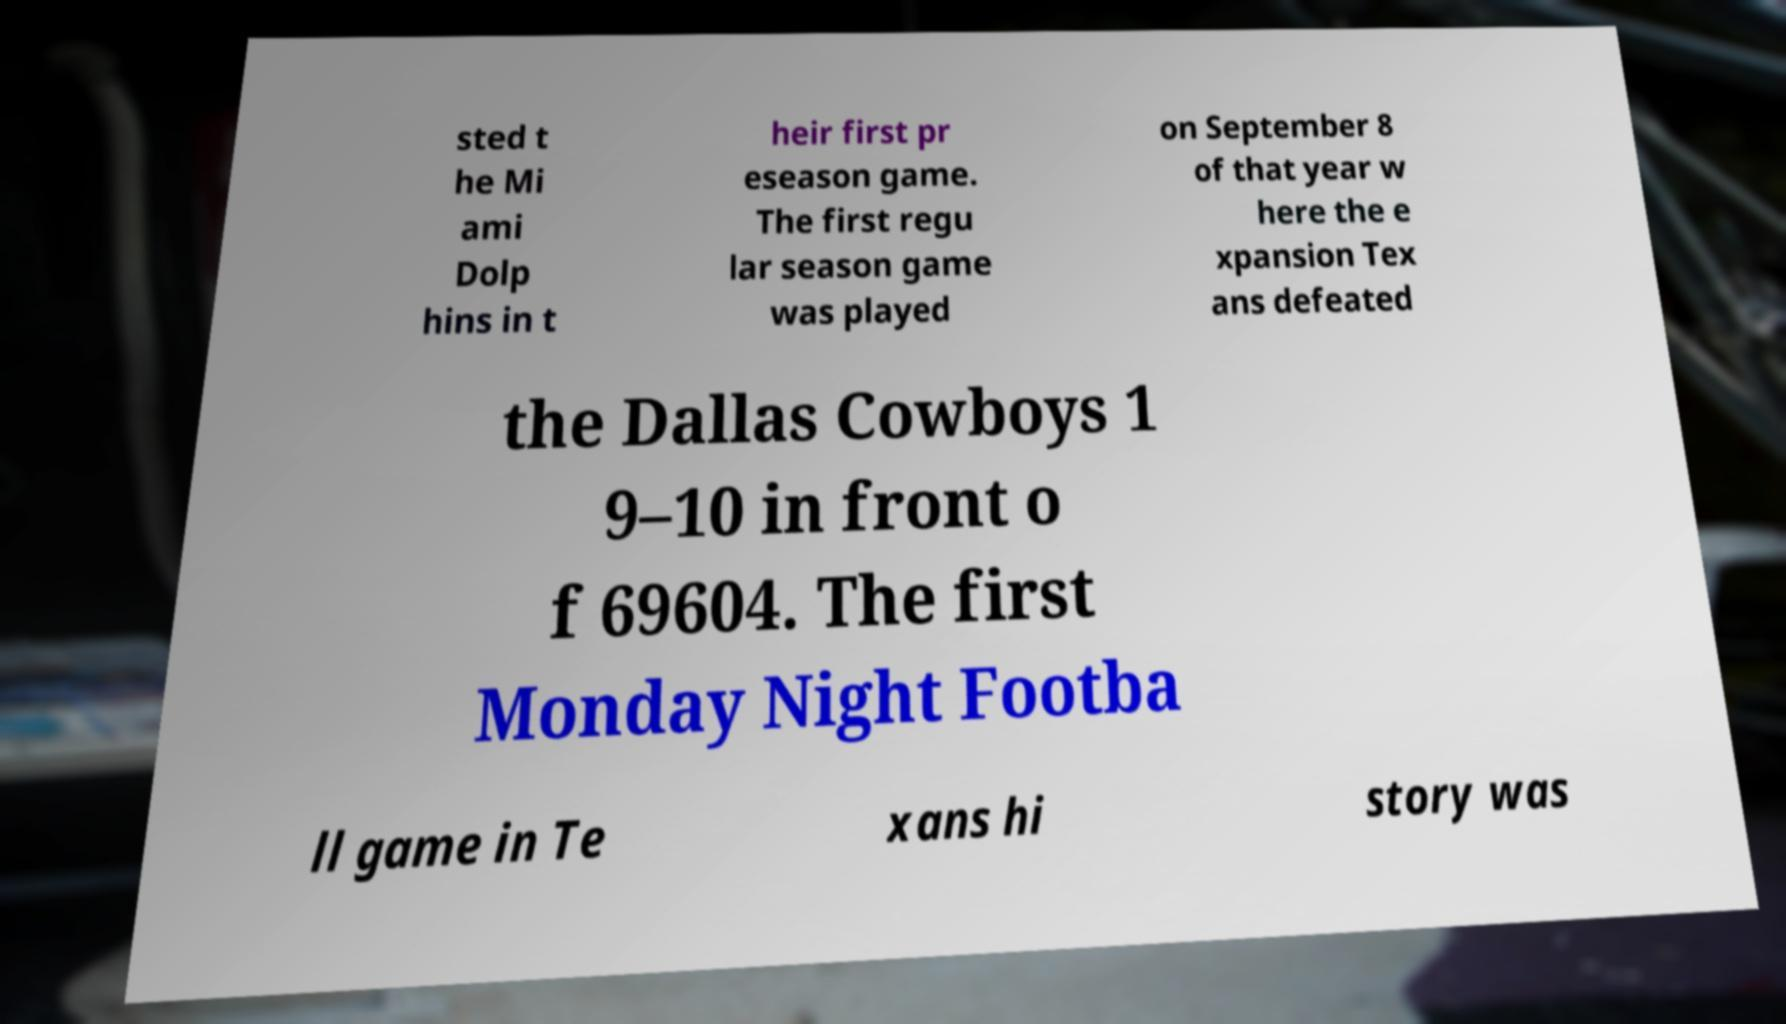What messages or text are displayed in this image? I need them in a readable, typed format. sted t he Mi ami Dolp hins in t heir first pr eseason game. The first regu lar season game was played on September 8 of that year w here the e xpansion Tex ans defeated the Dallas Cowboys 1 9–10 in front o f 69604. The first Monday Night Footba ll game in Te xans hi story was 